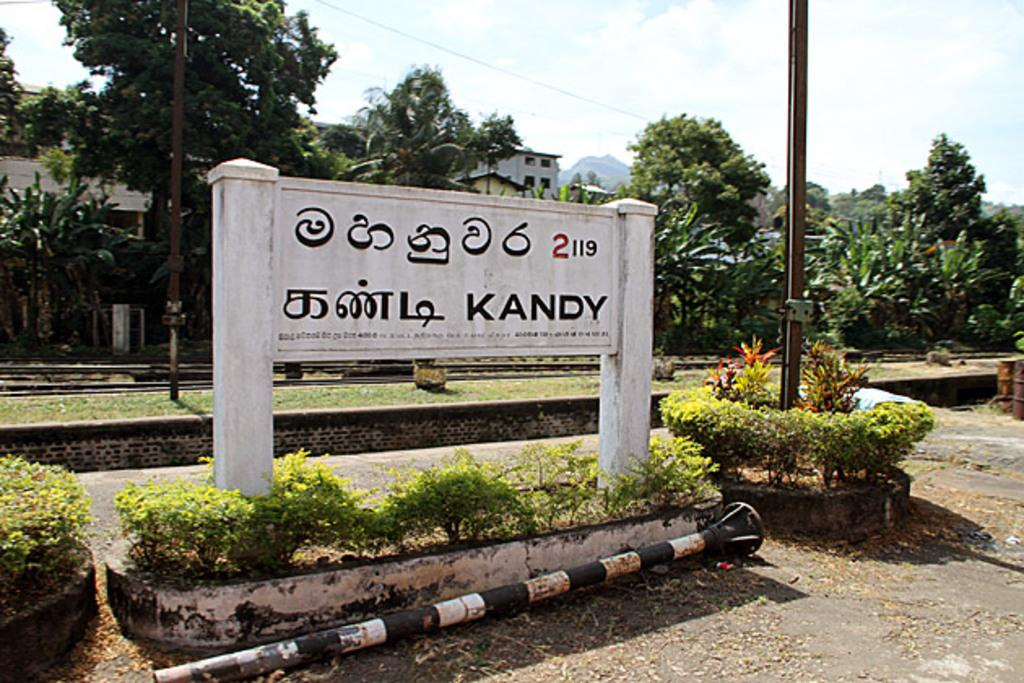What type of vegetation can be seen in the image? There are trees in the image. What type of structures are present in the image? There are houses in the image. What object can be seen standing upright in the image? There is a pole in the image. What is visible above the houses and trees in the image? The sky is visible in the image. What does the caption say about the trees in the image? There is no caption present in the image, so it is not possible to answer that question. How many cats can be seen climbing the trees in the image? There are no cats present in the image; it features trees, houses, and a pole. 